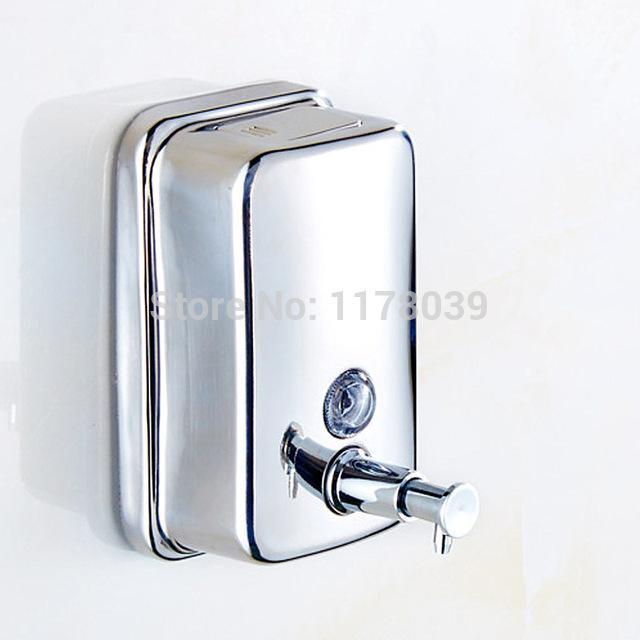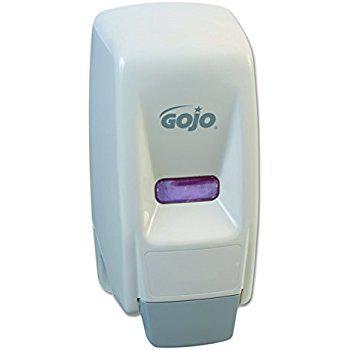The first image is the image on the left, the second image is the image on the right. Considering the images on both sides, is "in at least one image there are three wall soap dispensers." valid? Answer yes or no. No. The first image is the image on the left, the second image is the image on the right. For the images displayed, is the sentence "An image shows exactly three dispensers in a row, with at least two of them the same style." factually correct? Answer yes or no. No. 